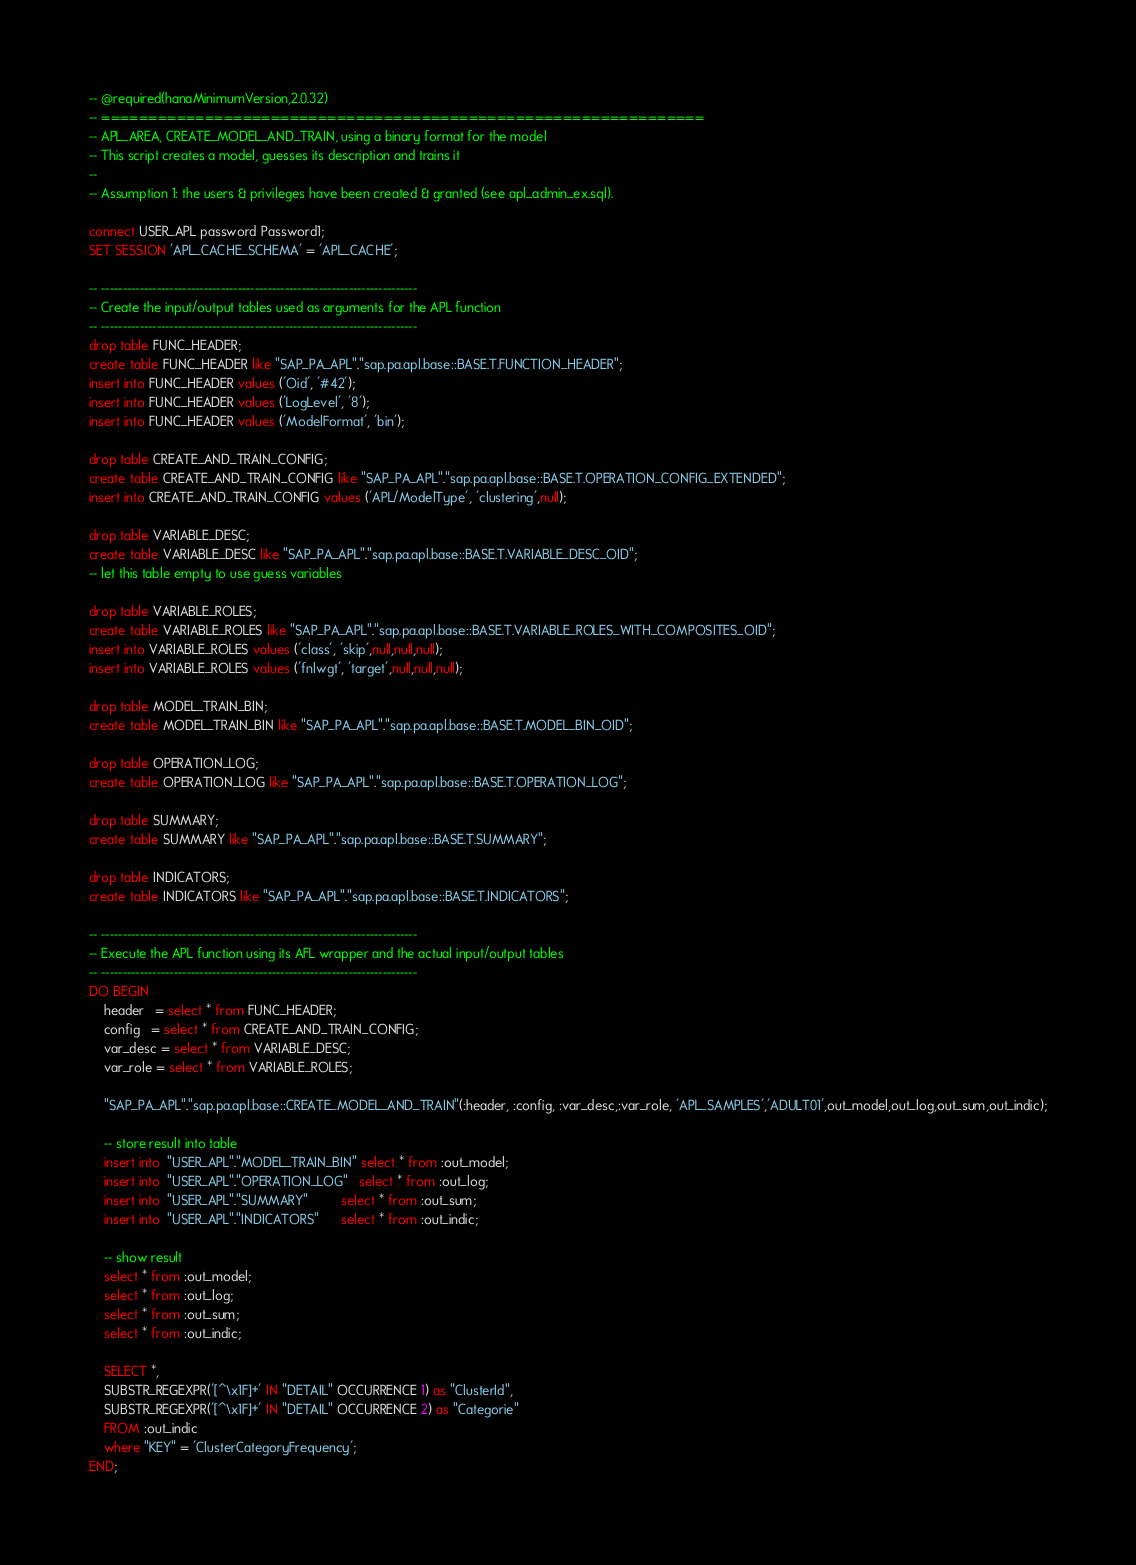<code> <loc_0><loc_0><loc_500><loc_500><_SQL_>-- @required(hanaMinimumVersion,2.0.32)
-- ================================================================
-- APL_AREA, CREATE_MODEL_AND_TRAIN, using a binary format for the model
-- This script creates a model, guesses its description and trains it
--
-- Assumption 1: the users & privileges have been created & granted (see apl_admin_ex.sql).

connect USER_APL password Password1;
SET SESSION 'APL_CACHE_SCHEMA' = 'APL_CACHE';

-- --------------------------------------------------------------------------
-- Create the input/output tables used as arguments for the APL function
-- --------------------------------------------------------------------------
drop table FUNC_HEADER;
create table FUNC_HEADER like "SAP_PA_APL"."sap.pa.apl.base::BASE.T.FUNCTION_HEADER";
insert into FUNC_HEADER values ('Oid', '#42');
insert into FUNC_HEADER values ('LogLevel', '8');
insert into FUNC_HEADER values ('ModelFormat', 'bin');

drop table CREATE_AND_TRAIN_CONFIG;
create table CREATE_AND_TRAIN_CONFIG like "SAP_PA_APL"."sap.pa.apl.base::BASE.T.OPERATION_CONFIG_EXTENDED";
insert into CREATE_AND_TRAIN_CONFIG values ('APL/ModelType', 'clustering',null);

drop table VARIABLE_DESC;
create table VARIABLE_DESC like "SAP_PA_APL"."sap.pa.apl.base::BASE.T.VARIABLE_DESC_OID";
-- let this table empty to use guess variables

drop table VARIABLE_ROLES;
create table VARIABLE_ROLES like "SAP_PA_APL"."sap.pa.apl.base::BASE.T.VARIABLE_ROLES_WITH_COMPOSITES_OID";
insert into VARIABLE_ROLES values ('class', 'skip',null,null,null);
insert into VARIABLE_ROLES values ('fnlwgt', 'target',null,null,null);

drop table MODEL_TRAIN_BIN;
create table MODEL_TRAIN_BIN like "SAP_PA_APL"."sap.pa.apl.base::BASE.T.MODEL_BIN_OID";

drop table OPERATION_LOG;
create table OPERATION_LOG like "SAP_PA_APL"."sap.pa.apl.base::BASE.T.OPERATION_LOG";

drop table SUMMARY;
create table SUMMARY like "SAP_PA_APL"."sap.pa.apl.base::BASE.T.SUMMARY";

drop table INDICATORS;
create table INDICATORS like "SAP_PA_APL"."sap.pa.apl.base::BASE.T.INDICATORS";

-- --------------------------------------------------------------------------
-- Execute the APL function using its AFL wrapper and the actual input/output tables
-- --------------------------------------------------------------------------
DO BEGIN     
    header   = select * from FUNC_HEADER;             
    config   = select * from CREATE_AND_TRAIN_CONFIG;            
    var_desc = select * from VARIABLE_DESC;              
    var_role = select * from VARIABLE_ROLES;  

    "SAP_PA_APL"."sap.pa.apl.base::CREATE_MODEL_AND_TRAIN"(:header, :config, :var_desc,:var_role, 'APL_SAMPLES','ADULT01',out_model,out_log,out_sum,out_indic);
    
    -- store result into table
    insert into  "USER_APL"."MODEL_TRAIN_BIN" select * from :out_model;
    insert into  "USER_APL"."OPERATION_LOG"   select * from :out_log;
    insert into  "USER_APL"."SUMMARY"         select * from :out_sum;
    insert into  "USER_APL"."INDICATORS"      select * from :out_indic;

	-- show result
	select * from :out_model;
	select * from :out_log;
	select * from :out_sum;
	select * from :out_indic;

	SELECT *, 
	SUBSTR_REGEXPR('[^\x1F]+' IN "DETAIL" OCCURRENCE 1) as "ClusterId", 
	SUBSTR_REGEXPR('[^\x1F]+' IN "DETAIL" OCCURRENCE 2) as "Categorie" 
	FROM :out_indic 
	where "KEY" = 'ClusterCategoryFrequency';
END;
</code> 